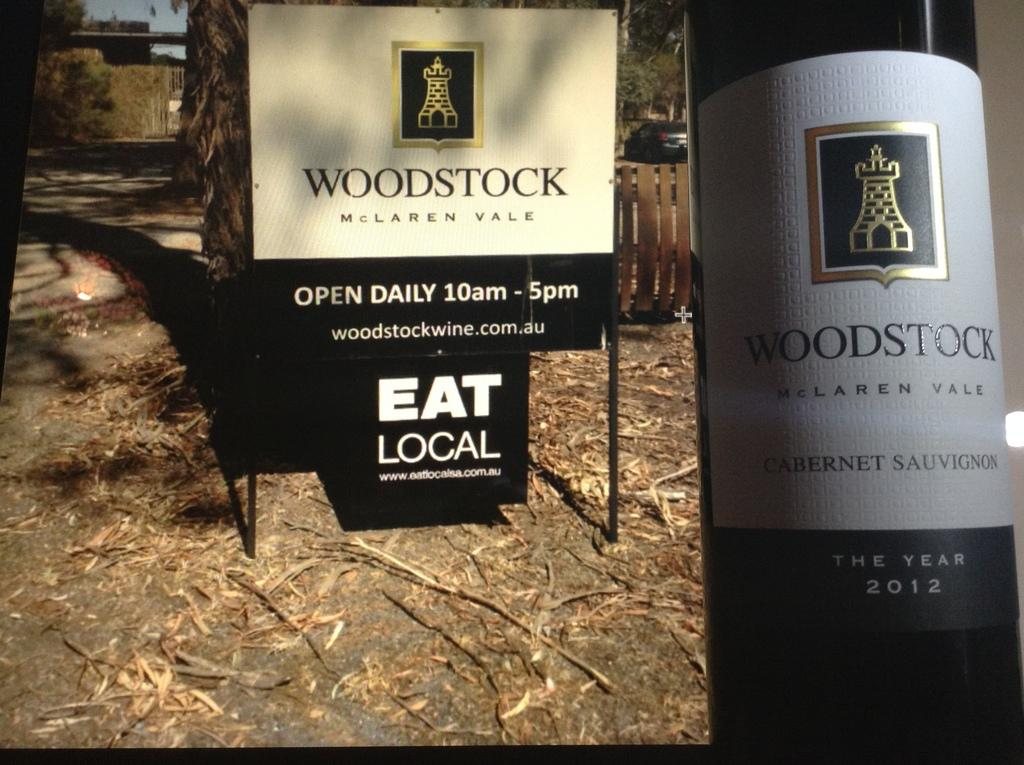<image>
Create a compact narrative representing the image presented. A bottle of Woodstock Mclaren Vale wine by a sign that says Eat Local. 